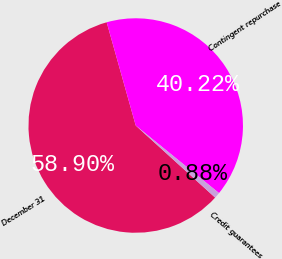<chart> <loc_0><loc_0><loc_500><loc_500><pie_chart><fcel>December 31<fcel>Contingent repurchase<fcel>Credit guarantees<nl><fcel>58.91%<fcel>40.22%<fcel>0.88%<nl></chart> 